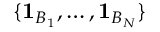Convert formula to latex. <formula><loc_0><loc_0><loc_500><loc_500>\{ 1 _ { B _ { 1 } } , \dots c , 1 _ { B _ { N } } \}</formula> 